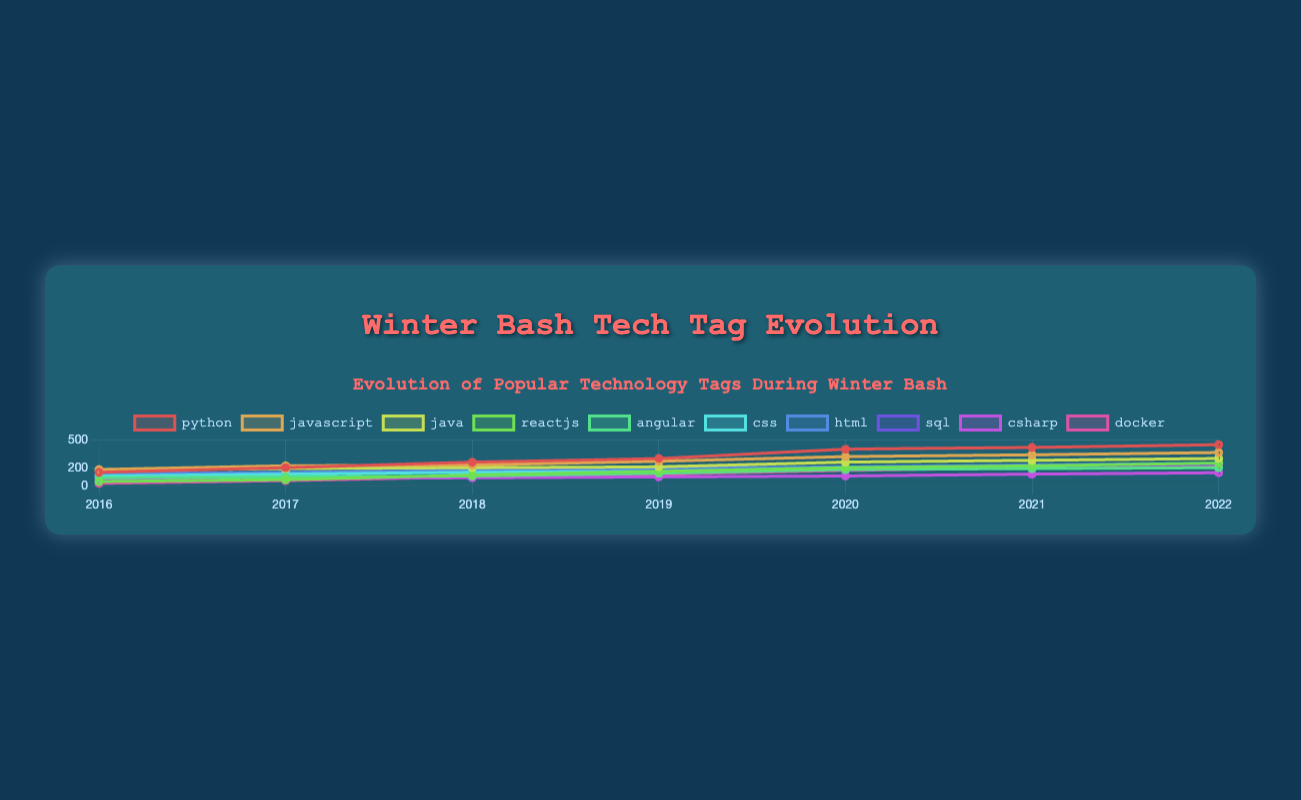Which tag saw the highest growth from 2016 to 2022? Compare the values for each tag in 2016 and 2022. Python increased from 150 to 450, which is the highest absolute growth.
Answer: Python Which tag had the least growth between 2016 and 2022? Compare the values of each tag in 2016 and 2022. Csharp grew from 80 to 145, which is the smallest increase.
Answer: Csharp Which year showed the biggest increase in the number of Python tags? Compare the year-over-year growth for Python. From 2019 to 2020, Python increased from 300 to 400, a growth of 100.
Answer: 2020 Which technology tag was ranked second highest in 2022? Compare the values of each tag in 2022. Python has the highest value at 450, and Javascript is second with 365.
Answer: Javascript How many tags had over 200 mentions in 2022? Check the 2022 values across all tags. Python (450), Javascript (365), Java (300), Reactjs (250), Html (250), Sql (240), and Docker (230) are all above 200.
Answer: 7 Which tag's line had the steepest slope between any two consecutive years? Evaluate the steepness of slopes between consecutive years for each tag. Reactjs from 2017 to 2018 jumped from 70 to 120, an increase of 50, which is the steepest slope.
Answer: Reactjs What is the average number of mentions for CSS across all years? Sum the CSS values and divide by the number of years. (110 + 130 + 150 + 160 + 180 + 190 + 200) = 1120. 1120/7 = 160
Answer: 160 Which tags consistently grew every year without any decline? Check for values that strictly increase each year. Python, Reactjs, Angular, CSS, Html, Sql, and Docker all show consistent growth.
Answer: Python, Reactjs, Angular, CSS, Html, Sql, Docker Which two tags had equal mentions in 2022? Check 2022 values for any tags with the same value. Reactjs and Html both have 250 mentions.
Answer: Reactjs, Html In which year did Docker surpass 100 mentions? Check Docker's values year by year. Docker surpassed 100 mentions in 2018 with 100 mentions.
Answer: 2018 